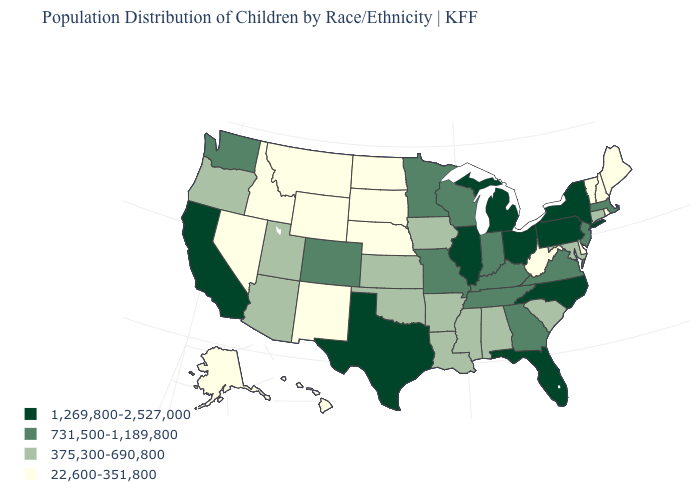What is the value of Maryland?
Short answer required. 375,300-690,800. What is the value of Pennsylvania?
Give a very brief answer. 1,269,800-2,527,000. Among the states that border North Dakota , which have the lowest value?
Quick response, please. Montana, South Dakota. What is the highest value in the West ?
Be succinct. 1,269,800-2,527,000. Name the states that have a value in the range 731,500-1,189,800?
Give a very brief answer. Colorado, Georgia, Indiana, Kentucky, Massachusetts, Minnesota, Missouri, New Jersey, Tennessee, Virginia, Washington, Wisconsin. Is the legend a continuous bar?
Answer briefly. No. Does New Mexico have the same value as New Hampshire?
Give a very brief answer. Yes. Does Tennessee have the lowest value in the USA?
Be succinct. No. Name the states that have a value in the range 22,600-351,800?
Quick response, please. Alaska, Delaware, Hawaii, Idaho, Maine, Montana, Nebraska, Nevada, New Hampshire, New Mexico, North Dakota, Rhode Island, South Dakota, Vermont, West Virginia, Wyoming. Is the legend a continuous bar?
Give a very brief answer. No. What is the value of Texas?
Quick response, please. 1,269,800-2,527,000. Among the states that border Texas , which have the lowest value?
Be succinct. New Mexico. Name the states that have a value in the range 1,269,800-2,527,000?
Answer briefly. California, Florida, Illinois, Michigan, New York, North Carolina, Ohio, Pennsylvania, Texas. What is the value of Wisconsin?
Short answer required. 731,500-1,189,800. What is the highest value in the USA?
Be succinct. 1,269,800-2,527,000. 